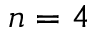<formula> <loc_0><loc_0><loc_500><loc_500>n = 4</formula> 